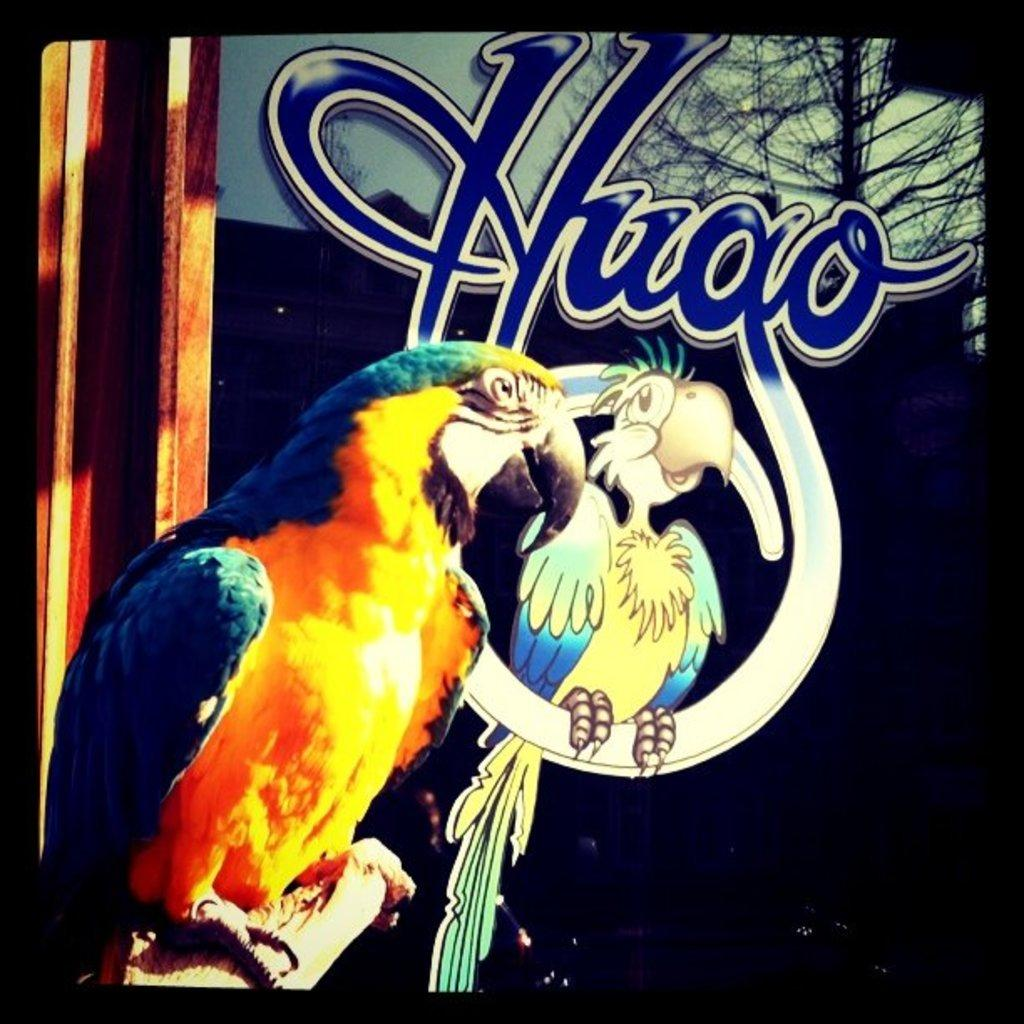What type of animal is in the image? There is a bird in the image. Can you describe the colors of the bird? The bird has yellow and blue colors. What can be seen in the background of the image? There is an art of a bird on the wall in the background. What color is the text in the image? There is blue color text in the image. What flavor of ice cream is being served in the image? There is no ice cream present in the image; it features a bird with yellow and blue colors. What type of canvas is used for the bird art in the image? The image does not provide information about the canvas used for the bird art in the background. 